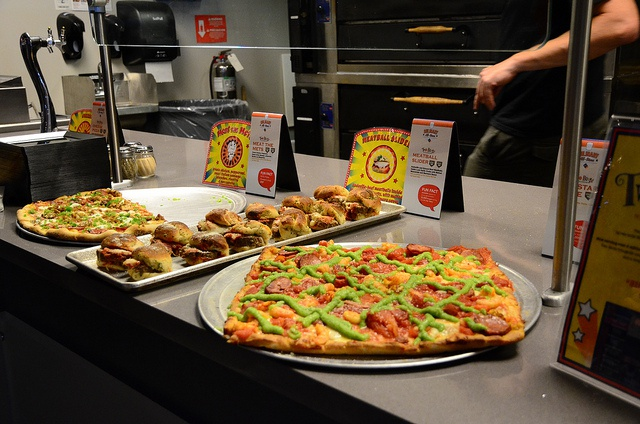Describe the objects in this image and their specific colors. I can see pizza in darkgray, orange, brown, olive, and red tones, people in darkgray, black, salmon, and maroon tones, oven in darkgray, black, and gray tones, oven in darkgray, black, maroon, olive, and tan tones, and pizza in darkgray, black, orange, and olive tones in this image. 